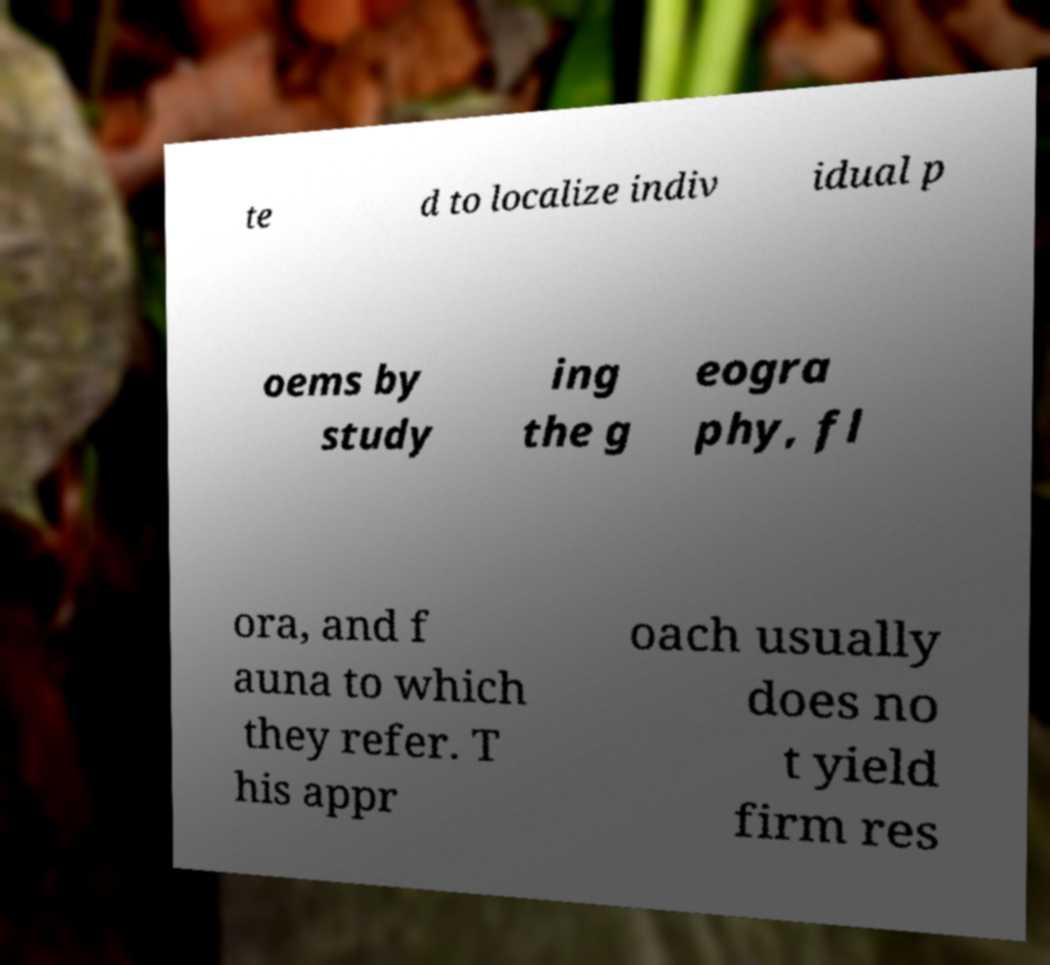Could you assist in decoding the text presented in this image and type it out clearly? te d to localize indiv idual p oems by study ing the g eogra phy, fl ora, and f auna to which they refer. T his appr oach usually does no t yield firm res 